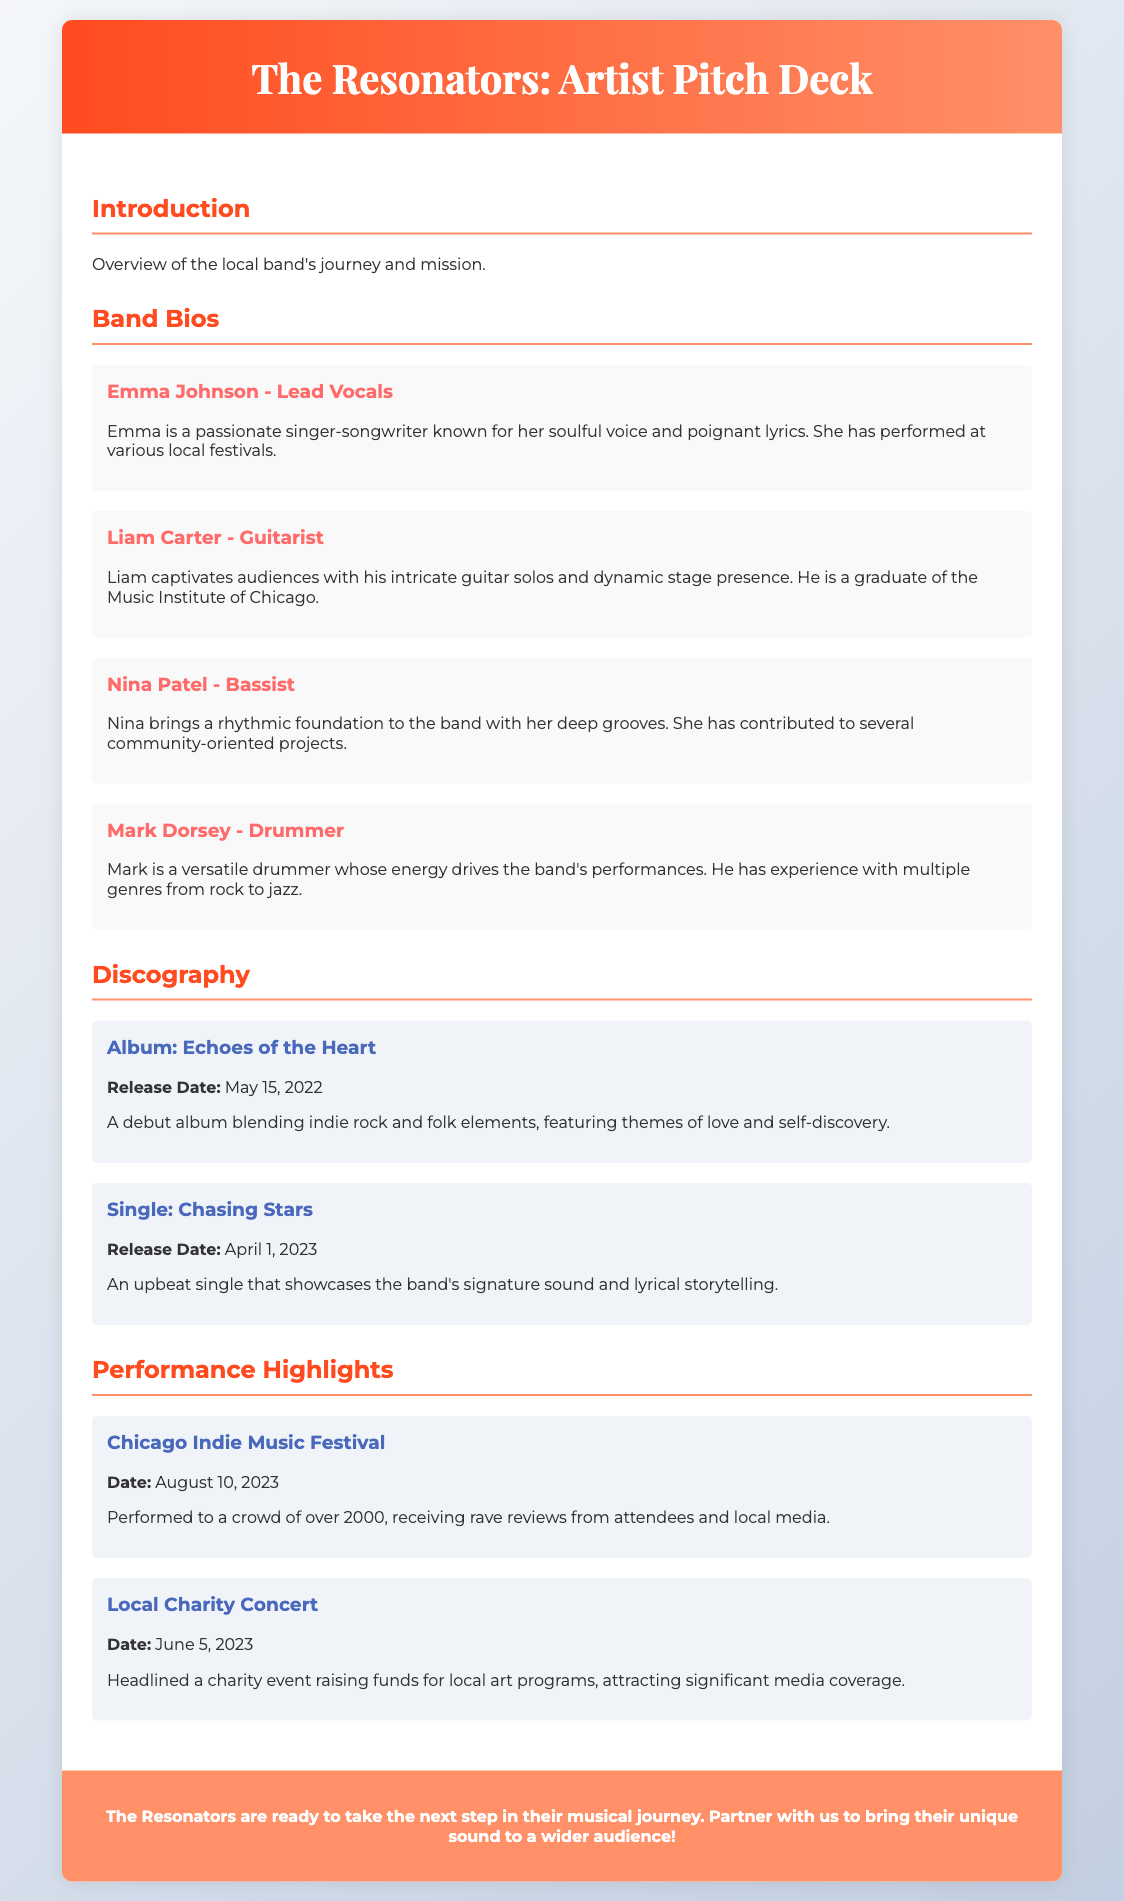what is the name of the band? The name of the band is mentioned in the document title.
Answer: The Resonators who is the lead vocalist? The document specifically lists the band members along with their roles.
Answer: Emma Johnson when was the debut album released? The release date of the debut album is explicitly provided in the Discography section.
Answer: May 15, 2022 which festival did they perform at in August 2023? The performance highlights section details the events they participated in.
Answer: Chicago Indie Music Festival what genre does the debut album blend? The document briefly describes the debut album, including its genre influences.
Answer: Indie rock and folk how many people attended the Chicago Indie Music Festival? The document states the approximate crowd size during their performance at this event.
Answer: over 2000 who is the guitarist? The names and roles of the band members are listed, making it clear who plays which instrument.
Answer: Liam Carter what is the title of their latest single? The latest single released by the band is outlined in the Discography section.
Answer: Chasing Stars what was the purpose of the Local Charity Concert? The performance highlights detail the charitable aspect of this specific concert.
Answer: raising funds for local art programs 